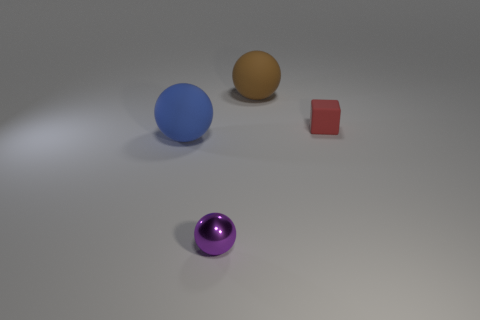There is a thing that is in front of the large ball that is in front of the red rubber thing that is behind the blue thing; how big is it?
Ensure brevity in your answer.  Small. How many other things are there of the same size as the purple thing?
Keep it short and to the point. 1. What size is the matte ball behind the tiny red block?
Provide a short and direct response. Large. Are there any other things that have the same color as the small matte object?
Your answer should be compact. No. Is the object that is left of the small purple metal object made of the same material as the tiny purple object?
Provide a short and direct response. No. What number of tiny objects are both to the left of the red object and on the right side of the purple sphere?
Offer a terse response. 0. What is the size of the red cube right of the big matte ball that is left of the purple thing?
Offer a very short reply. Small. Are there any other things that are the same material as the small red cube?
Ensure brevity in your answer.  Yes. Are there more brown matte cylinders than brown matte spheres?
Your answer should be very brief. No. There is a large rubber object in front of the brown matte object; is it the same color as the rubber thing that is behind the cube?
Offer a very short reply. No. 